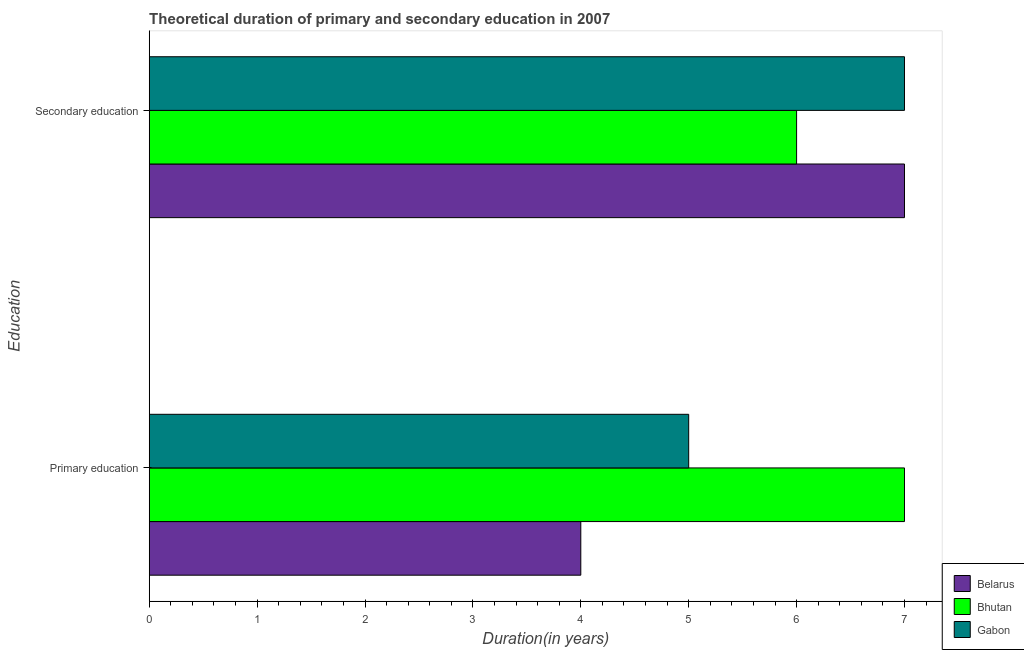How many different coloured bars are there?
Provide a succinct answer. 3. How many groups of bars are there?
Keep it short and to the point. 2. Are the number of bars on each tick of the Y-axis equal?
Provide a short and direct response. Yes. How many bars are there on the 2nd tick from the bottom?
Make the answer very short. 3. What is the label of the 1st group of bars from the top?
Provide a succinct answer. Secondary education. What is the duration of primary education in Belarus?
Make the answer very short. 4. Across all countries, what is the maximum duration of secondary education?
Keep it short and to the point. 7. Across all countries, what is the minimum duration of primary education?
Your answer should be compact. 4. In which country was the duration of primary education maximum?
Make the answer very short. Bhutan. In which country was the duration of secondary education minimum?
Ensure brevity in your answer.  Bhutan. What is the total duration of primary education in the graph?
Your response must be concise. 16. What is the difference between the duration of secondary education in Bhutan and that in Belarus?
Your answer should be very brief. -1. What is the difference between the duration of secondary education in Bhutan and the duration of primary education in Belarus?
Give a very brief answer. 2. What is the average duration of primary education per country?
Offer a very short reply. 5.33. What is the difference between the duration of primary education and duration of secondary education in Bhutan?
Provide a short and direct response. 1. What is the ratio of the duration of primary education in Belarus to that in Gabon?
Offer a very short reply. 0.8. Is the duration of secondary education in Bhutan less than that in Belarus?
Provide a succinct answer. Yes. What does the 3rd bar from the top in Secondary education represents?
Give a very brief answer. Belarus. What does the 1st bar from the bottom in Primary education represents?
Keep it short and to the point. Belarus. Are all the bars in the graph horizontal?
Keep it short and to the point. Yes. Are the values on the major ticks of X-axis written in scientific E-notation?
Ensure brevity in your answer.  No. Does the graph contain any zero values?
Offer a very short reply. No. Does the graph contain grids?
Offer a very short reply. No. What is the title of the graph?
Your answer should be very brief. Theoretical duration of primary and secondary education in 2007. What is the label or title of the X-axis?
Your response must be concise. Duration(in years). What is the label or title of the Y-axis?
Your response must be concise. Education. What is the Duration(in years) of Bhutan in Primary education?
Give a very brief answer. 7. What is the Duration(in years) in Gabon in Primary education?
Keep it short and to the point. 5. What is the Duration(in years) in Belarus in Secondary education?
Give a very brief answer. 7. Across all Education, what is the maximum Duration(in years) in Belarus?
Your answer should be compact. 7. Across all Education, what is the maximum Duration(in years) in Gabon?
Ensure brevity in your answer.  7. Across all Education, what is the minimum Duration(in years) in Belarus?
Your answer should be very brief. 4. Across all Education, what is the minimum Duration(in years) in Bhutan?
Offer a very short reply. 6. What is the total Duration(in years) in Belarus in the graph?
Ensure brevity in your answer.  11. What is the total Duration(in years) of Gabon in the graph?
Your answer should be very brief. 12. What is the difference between the Duration(in years) of Belarus in Primary education and that in Secondary education?
Provide a short and direct response. -3. What is the difference between the Duration(in years) in Gabon in Primary education and that in Secondary education?
Offer a very short reply. -2. What is the difference between the Duration(in years) of Belarus in Primary education and the Duration(in years) of Bhutan in Secondary education?
Provide a short and direct response. -2. What is the difference between the Duration(in years) in Bhutan in Primary education and the Duration(in years) in Gabon in Secondary education?
Keep it short and to the point. 0. What is the average Duration(in years) of Gabon per Education?
Your response must be concise. 6. What is the difference between the Duration(in years) in Belarus and Duration(in years) in Gabon in Primary education?
Offer a terse response. -1. What is the ratio of the Duration(in years) of Bhutan in Primary education to that in Secondary education?
Give a very brief answer. 1.17. What is the difference between the highest and the second highest Duration(in years) of Belarus?
Ensure brevity in your answer.  3. What is the difference between the highest and the second highest Duration(in years) of Bhutan?
Your response must be concise. 1. What is the difference between the highest and the second highest Duration(in years) of Gabon?
Ensure brevity in your answer.  2. What is the difference between the highest and the lowest Duration(in years) in Bhutan?
Your response must be concise. 1. What is the difference between the highest and the lowest Duration(in years) of Gabon?
Ensure brevity in your answer.  2. 